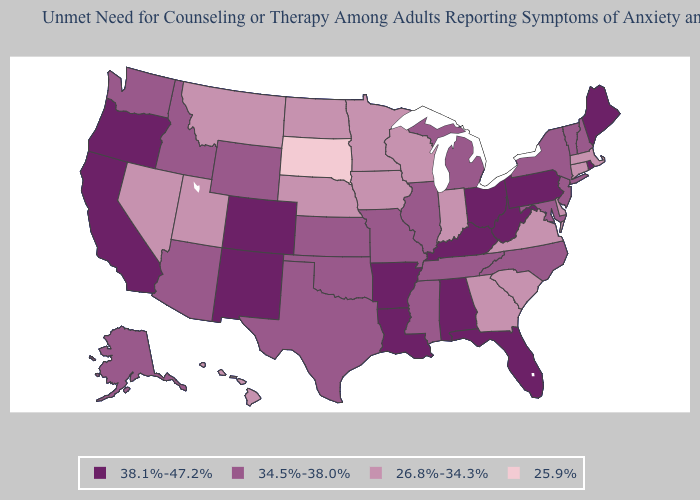Does Oklahoma have the lowest value in the South?
Be succinct. No. Name the states that have a value in the range 26.8%-34.3%?
Concise answer only. Connecticut, Delaware, Georgia, Hawaii, Indiana, Iowa, Massachusetts, Minnesota, Montana, Nebraska, Nevada, North Dakota, South Carolina, Utah, Virginia, Wisconsin. Name the states that have a value in the range 26.8%-34.3%?
Write a very short answer. Connecticut, Delaware, Georgia, Hawaii, Indiana, Iowa, Massachusetts, Minnesota, Montana, Nebraska, Nevada, North Dakota, South Carolina, Utah, Virginia, Wisconsin. Among the states that border Oregon , does Nevada have the lowest value?
Answer briefly. Yes. What is the value of New Hampshire?
Short answer required. 34.5%-38.0%. Name the states that have a value in the range 25.9%?
Write a very short answer. South Dakota. What is the value of New York?
Give a very brief answer. 34.5%-38.0%. Among the states that border Minnesota , does Wisconsin have the highest value?
Keep it brief. Yes. What is the value of Virginia?
Be succinct. 26.8%-34.3%. Among the states that border Oklahoma , does Arkansas have the highest value?
Keep it brief. Yes. Which states have the highest value in the USA?
Short answer required. Alabama, Arkansas, California, Colorado, Florida, Kentucky, Louisiana, Maine, New Mexico, Ohio, Oregon, Pennsylvania, Rhode Island, West Virginia. Which states hav the highest value in the West?
Quick response, please. California, Colorado, New Mexico, Oregon. Name the states that have a value in the range 34.5%-38.0%?
Concise answer only. Alaska, Arizona, Idaho, Illinois, Kansas, Maryland, Michigan, Mississippi, Missouri, New Hampshire, New Jersey, New York, North Carolina, Oklahoma, Tennessee, Texas, Vermont, Washington, Wyoming. What is the value of Alaska?
Be succinct. 34.5%-38.0%. Does the first symbol in the legend represent the smallest category?
Short answer required. No. 